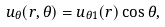Convert formula to latex. <formula><loc_0><loc_0><loc_500><loc_500>u _ { \theta } ( r , \theta ) = u _ { \theta 1 } ( r ) \cos \theta ,</formula> 